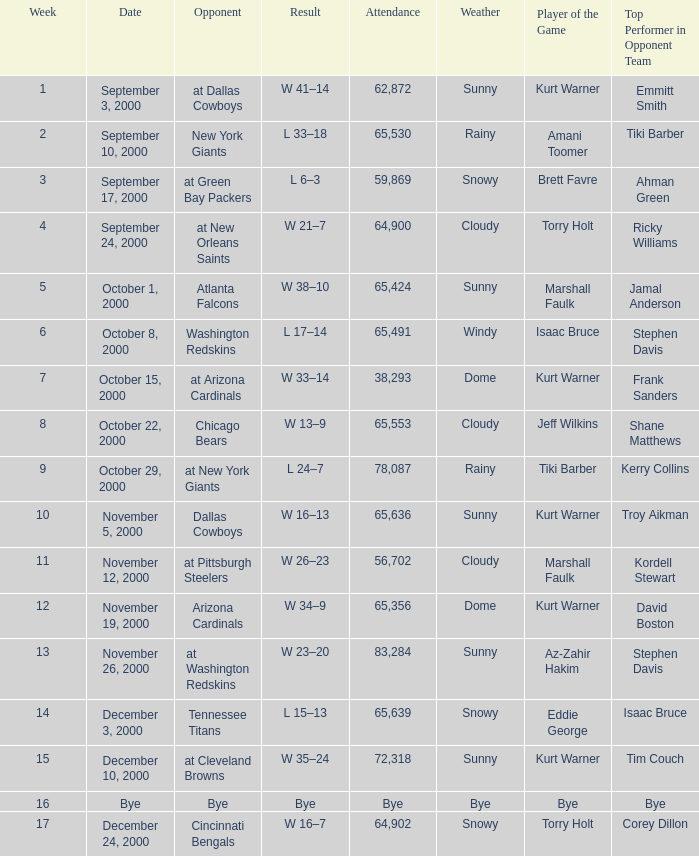What was the attendance for week 2? 65530.0. 